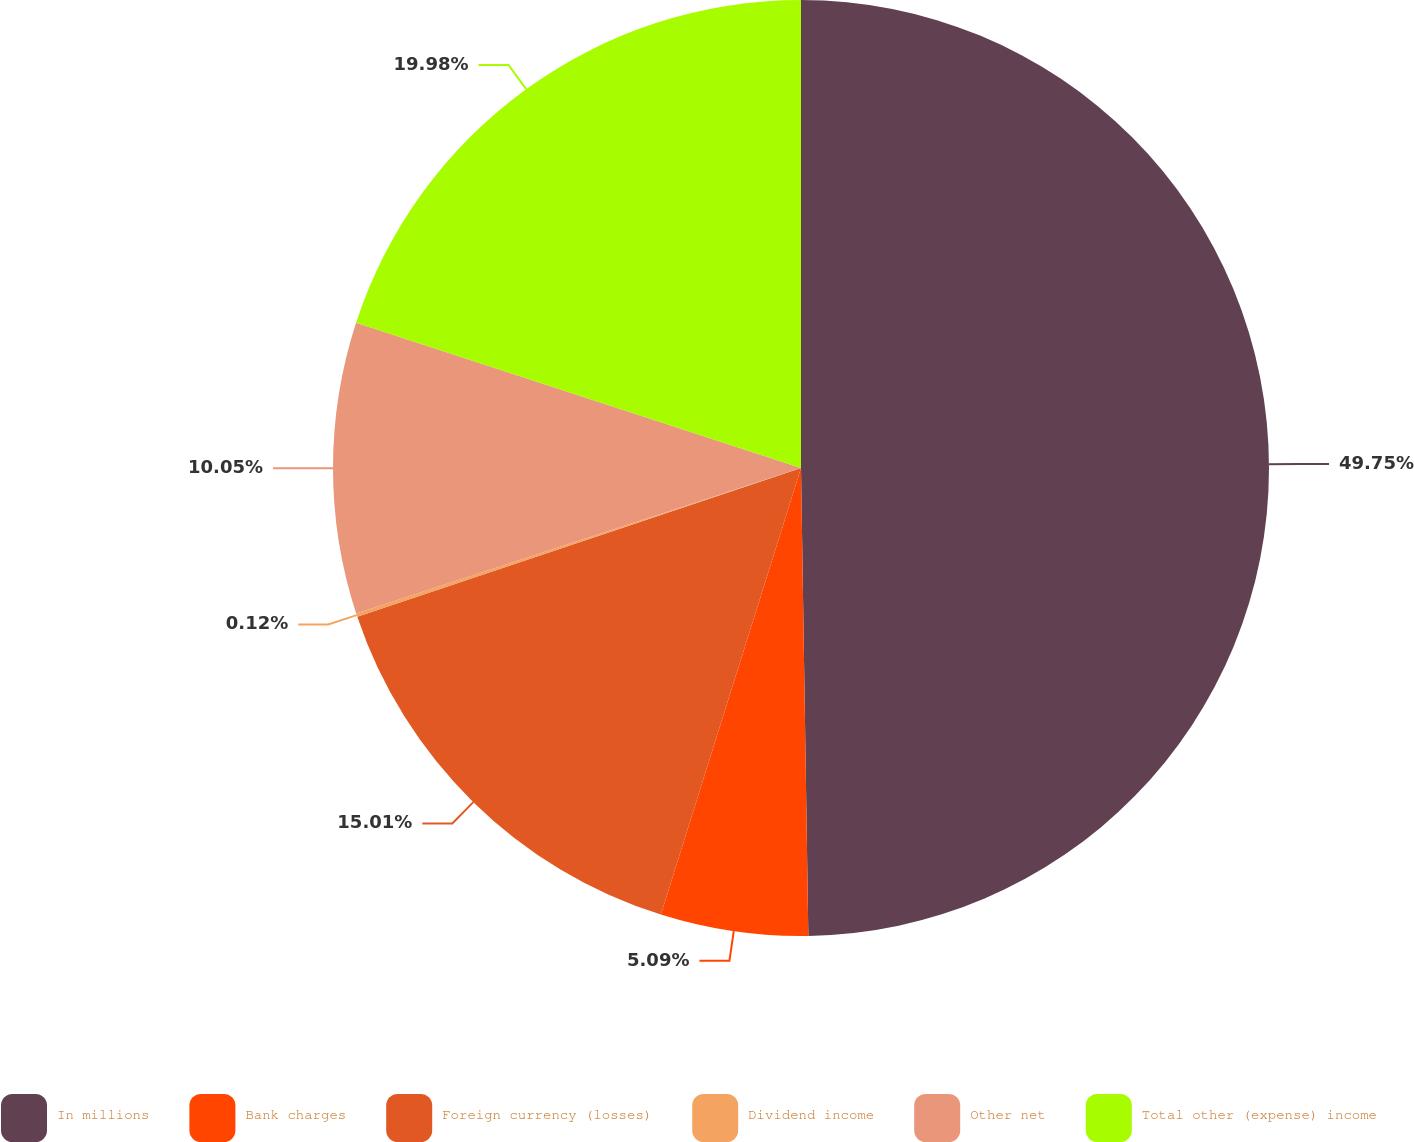Convert chart to OTSL. <chart><loc_0><loc_0><loc_500><loc_500><pie_chart><fcel>In millions<fcel>Bank charges<fcel>Foreign currency (losses)<fcel>Dividend income<fcel>Other net<fcel>Total other (expense) income<nl><fcel>49.75%<fcel>5.09%<fcel>15.01%<fcel>0.12%<fcel>10.05%<fcel>19.98%<nl></chart> 